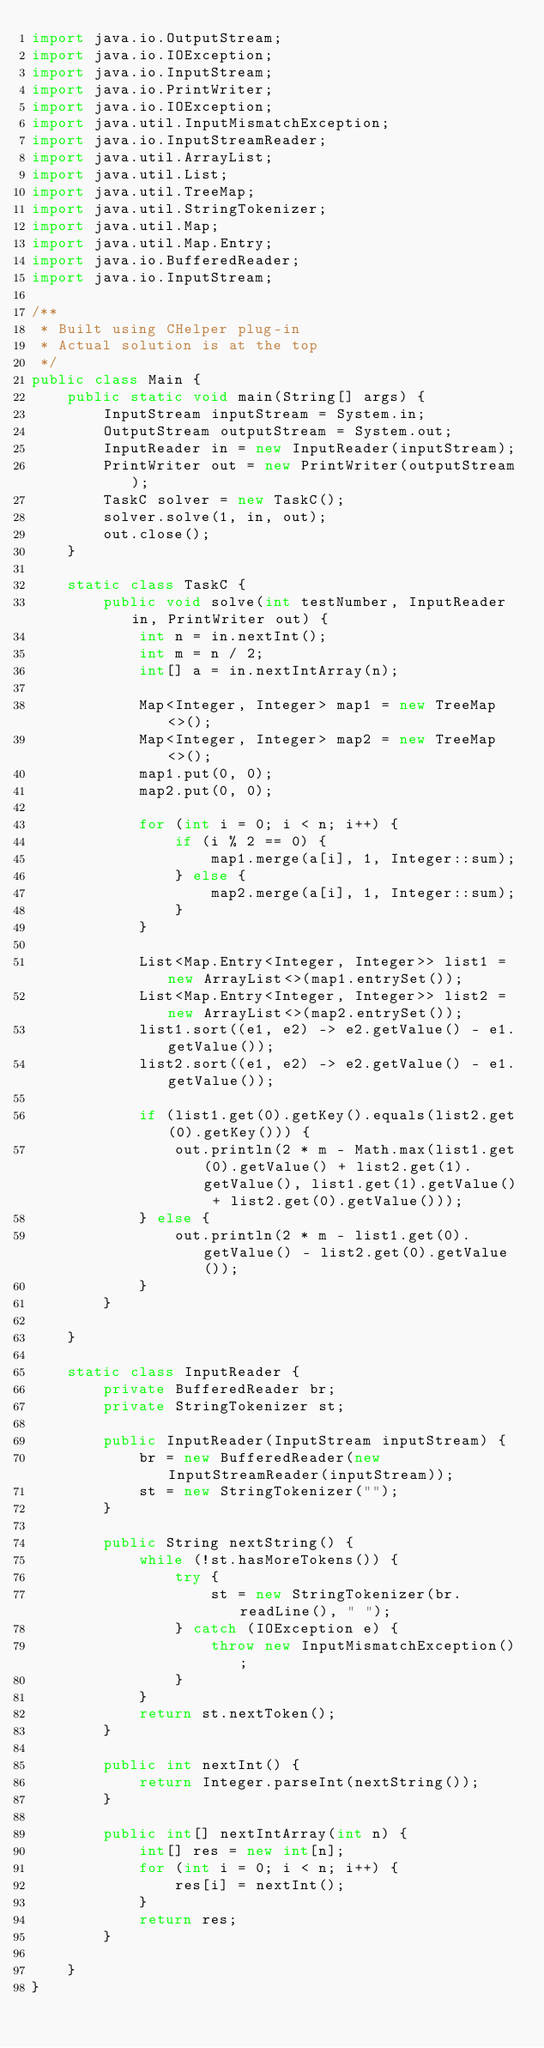Convert code to text. <code><loc_0><loc_0><loc_500><loc_500><_Java_>import java.io.OutputStream;
import java.io.IOException;
import java.io.InputStream;
import java.io.PrintWriter;
import java.io.IOException;
import java.util.InputMismatchException;
import java.io.InputStreamReader;
import java.util.ArrayList;
import java.util.List;
import java.util.TreeMap;
import java.util.StringTokenizer;
import java.util.Map;
import java.util.Map.Entry;
import java.io.BufferedReader;
import java.io.InputStream;

/**
 * Built using CHelper plug-in
 * Actual solution is at the top
 */
public class Main {
    public static void main(String[] args) {
        InputStream inputStream = System.in;
        OutputStream outputStream = System.out;
        InputReader in = new InputReader(inputStream);
        PrintWriter out = new PrintWriter(outputStream);
        TaskC solver = new TaskC();
        solver.solve(1, in, out);
        out.close();
    }

    static class TaskC {
        public void solve(int testNumber, InputReader in, PrintWriter out) {
            int n = in.nextInt();
            int m = n / 2;
            int[] a = in.nextIntArray(n);

            Map<Integer, Integer> map1 = new TreeMap<>();
            Map<Integer, Integer> map2 = new TreeMap<>();
            map1.put(0, 0);
            map2.put(0, 0);

            for (int i = 0; i < n; i++) {
                if (i % 2 == 0) {
                    map1.merge(a[i], 1, Integer::sum);
                } else {
                    map2.merge(a[i], 1, Integer::sum);
                }
            }

            List<Map.Entry<Integer, Integer>> list1 = new ArrayList<>(map1.entrySet());
            List<Map.Entry<Integer, Integer>> list2 = new ArrayList<>(map2.entrySet());
            list1.sort((e1, e2) -> e2.getValue() - e1.getValue());
            list2.sort((e1, e2) -> e2.getValue() - e1.getValue());

            if (list1.get(0).getKey().equals(list2.get(0).getKey())) {
                out.println(2 * m - Math.max(list1.get(0).getValue() + list2.get(1).getValue(), list1.get(1).getValue() + list2.get(0).getValue()));
            } else {
                out.println(2 * m - list1.get(0).getValue() - list2.get(0).getValue());
            }
        }

    }

    static class InputReader {
        private BufferedReader br;
        private StringTokenizer st;

        public InputReader(InputStream inputStream) {
            br = new BufferedReader(new InputStreamReader(inputStream));
            st = new StringTokenizer("");
        }

        public String nextString() {
            while (!st.hasMoreTokens()) {
                try {
                    st = new StringTokenizer(br.readLine(), " ");
                } catch (IOException e) {
                    throw new InputMismatchException();
                }
            }
            return st.nextToken();
        }

        public int nextInt() {
            return Integer.parseInt(nextString());
        }

        public int[] nextIntArray(int n) {
            int[] res = new int[n];
            for (int i = 0; i < n; i++) {
                res[i] = nextInt();
            }
            return res;
        }

    }
}

</code> 